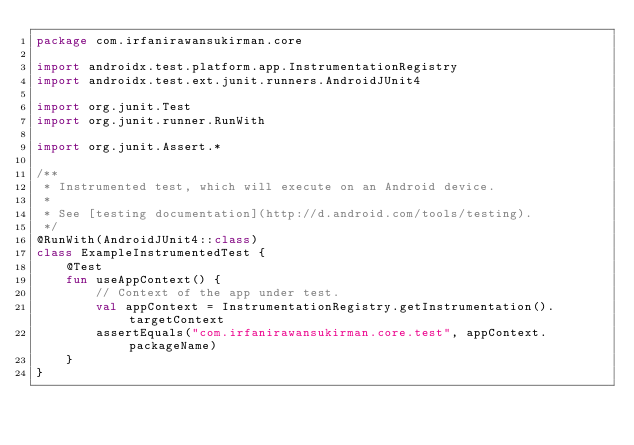Convert code to text. <code><loc_0><loc_0><loc_500><loc_500><_Kotlin_>package com.irfanirawansukirman.core

import androidx.test.platform.app.InstrumentationRegistry
import androidx.test.ext.junit.runners.AndroidJUnit4

import org.junit.Test
import org.junit.runner.RunWith

import org.junit.Assert.*

/**
 * Instrumented test, which will execute on an Android device.
 *
 * See [testing documentation](http://d.android.com/tools/testing).
 */
@RunWith(AndroidJUnit4::class)
class ExampleInstrumentedTest {
    @Test
    fun useAppContext() {
        // Context of the app under test.
        val appContext = InstrumentationRegistry.getInstrumentation().targetContext
        assertEquals("com.irfanirawansukirman.core.test", appContext.packageName)
    }
}</code> 